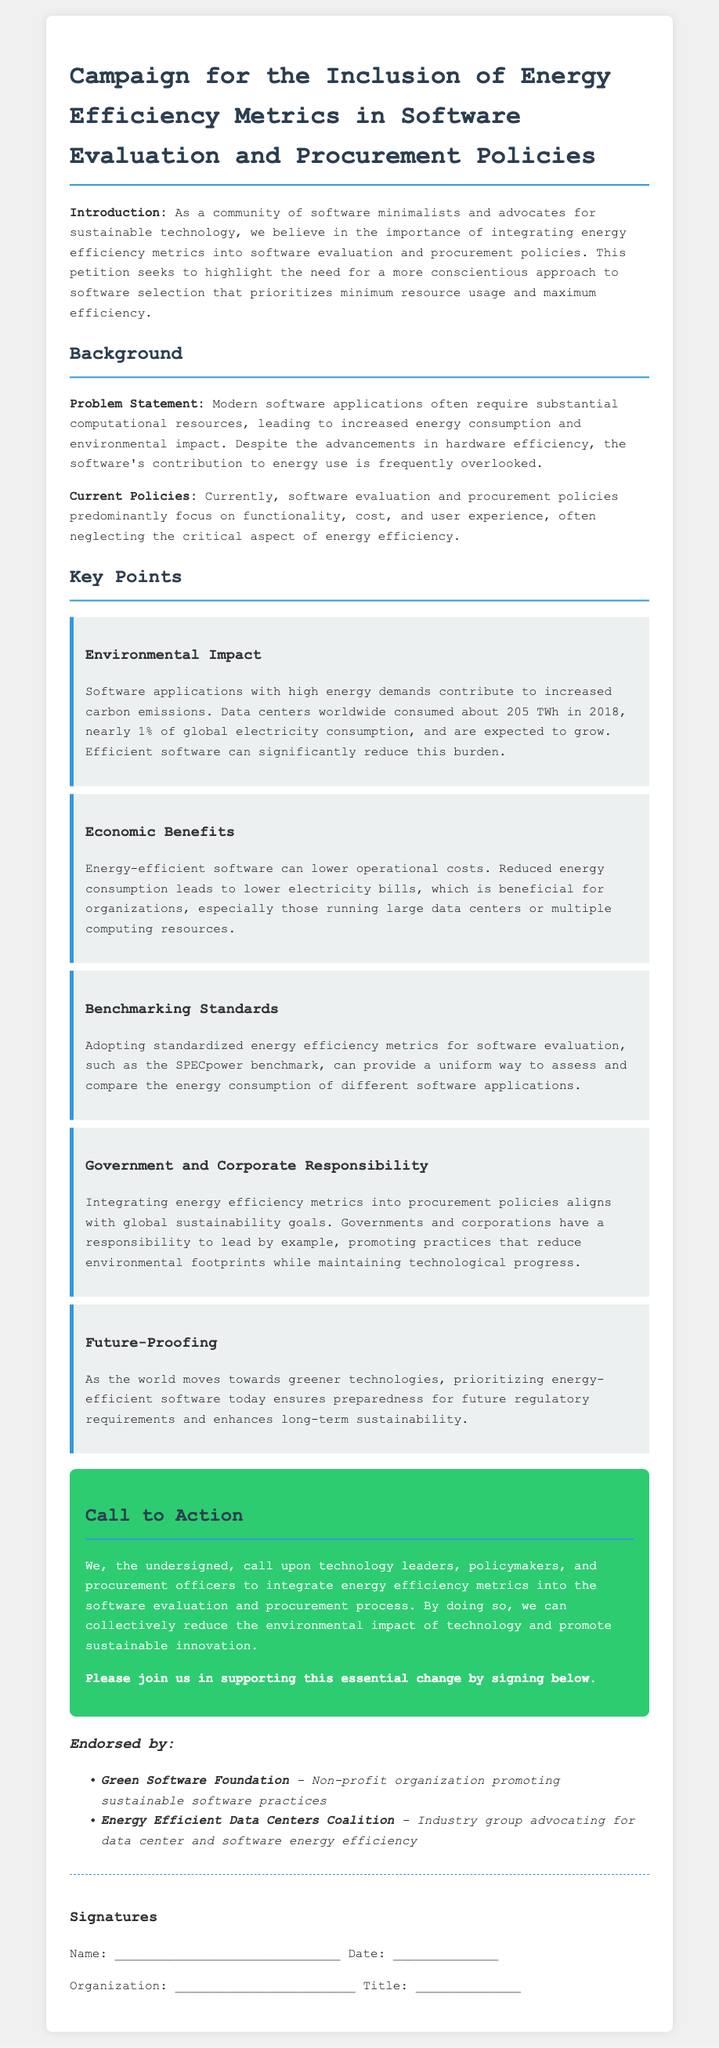What is the title of the petition? The title summarizes the main focus of the document which is about advocating for specific energy metrics in software practices.
Answer: Campaign for the Inclusion of Energy Efficiency Metrics in Software Evaluation and Procurement Policies What year did data centers consume about 205 TWh? The document provides a specific figure along with the year of consumption which highlights the scale of energy use by data centers.
Answer: 2018 Which standards are recommended for benchmarking energy efficiency? The petition mentions a specific benchmarking standard that can be used to evaluate software energy efficiency.
Answer: SPECpower What organization promotes sustainable software practices? The document lists organizations that endorse the petition, including one that specifically focuses on sustainable practices in software.
Answer: Green Software Foundation What percentage of global electricity consumption did data centers represent in 2018? The document states this percentage to illustrate the impact of data centers on energy use globally.
Answer: nearly 1% What are the economic benefits mentioned for energy-efficient software? The petition highlights a specific financial advantage for organizations that utilize energy-efficient software.
Answer: lower operational costs Who has a responsibility to lead by example according to the petition? This question focuses on the stakeholders discussed in the document regarding the integration of energy metrics.
Answer: Governments and corporations What is the main call to action in the petition? The document states a clear directive directed towards specific groups to promote energy efficiency in software.
Answer: integrate energy efficiency metrics into the software evaluation and procurement process 